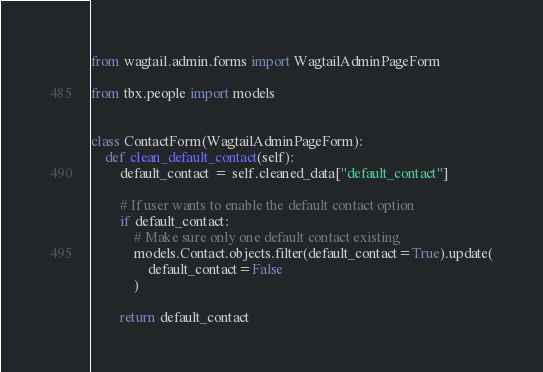Convert code to text. <code><loc_0><loc_0><loc_500><loc_500><_Python_>from wagtail.admin.forms import WagtailAdminPageForm

from tbx.people import models


class ContactForm(WagtailAdminPageForm):
    def clean_default_contact(self):
        default_contact = self.cleaned_data["default_contact"]

        # If user wants to enable the default contact option
        if default_contact:
            # Make sure only one default contact existing
            models.Contact.objects.filter(default_contact=True).update(
                default_contact=False
            )

        return default_contact
</code> 